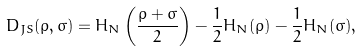<formula> <loc_0><loc_0><loc_500><loc_500>D _ { J S } ( \rho , \sigma ) = H _ { N } \left ( \frac { \rho + \sigma } { 2 } \right ) - \frac { 1 } { 2 } H _ { N } ( \rho ) - \frac { 1 } { 2 } H _ { N } ( \sigma ) ,</formula> 